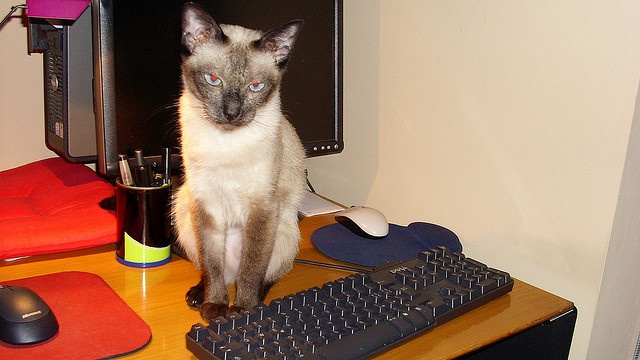Describe the objects in this image and their specific colors. I can see cat in tan, beige, and gray tones, tv in tan, black, maroon, gray, and darkgray tones, keyboard in tan, black, gray, and darkgray tones, cup in tan, black, maroon, and yellow tones, and mouse in tan, black, maroon, and gray tones in this image. 